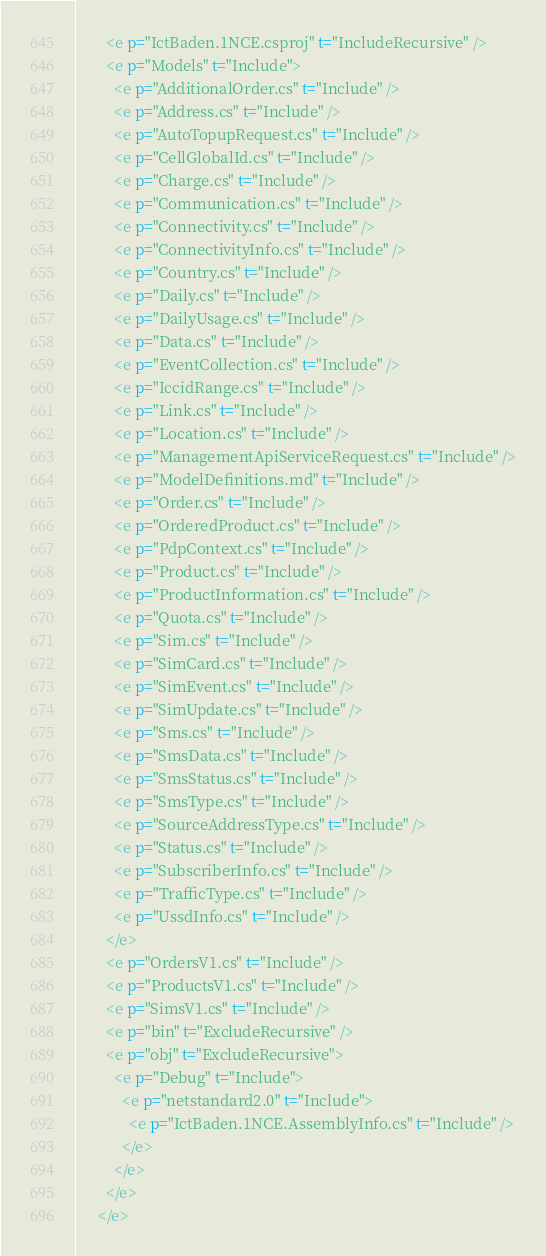<code> <loc_0><loc_0><loc_500><loc_500><_XML_>        <e p="IctBaden.1NCE.csproj" t="IncludeRecursive" />
        <e p="Models" t="Include">
          <e p="AdditionalOrder.cs" t="Include" />
          <e p="Address.cs" t="Include" />
          <e p="AutoTopupRequest.cs" t="Include" />
          <e p="CellGlobalId.cs" t="Include" />
          <e p="Charge.cs" t="Include" />
          <e p="Communication.cs" t="Include" />
          <e p="Connectivity.cs" t="Include" />
          <e p="ConnectivityInfo.cs" t="Include" />
          <e p="Country.cs" t="Include" />
          <e p="Daily.cs" t="Include" />
          <e p="DailyUsage.cs" t="Include" />
          <e p="Data.cs" t="Include" />
          <e p="EventCollection.cs" t="Include" />
          <e p="IccidRange.cs" t="Include" />
          <e p="Link.cs" t="Include" />
          <e p="Location.cs" t="Include" />
          <e p="ManagementApiServiceRequest.cs" t="Include" />
          <e p="ModelDefinitions.md" t="Include" />
          <e p="Order.cs" t="Include" />
          <e p="OrderedProduct.cs" t="Include" />
          <e p="PdpContext.cs" t="Include" />
          <e p="Product.cs" t="Include" />
          <e p="ProductInformation.cs" t="Include" />
          <e p="Quota.cs" t="Include" />
          <e p="Sim.cs" t="Include" />
          <e p="SimCard.cs" t="Include" />
          <e p="SimEvent.cs" t="Include" />
          <e p="SimUpdate.cs" t="Include" />
          <e p="Sms.cs" t="Include" />
          <e p="SmsData.cs" t="Include" />
          <e p="SmsStatus.cs" t="Include" />
          <e p="SmsType.cs" t="Include" />
          <e p="SourceAddressType.cs" t="Include" />
          <e p="Status.cs" t="Include" />
          <e p="SubscriberInfo.cs" t="Include" />
          <e p="TrafficType.cs" t="Include" />
          <e p="UssdInfo.cs" t="Include" />
        </e>
        <e p="OrdersV1.cs" t="Include" />
        <e p="ProductsV1.cs" t="Include" />
        <e p="SimsV1.cs" t="Include" />
        <e p="bin" t="ExcludeRecursive" />
        <e p="obj" t="ExcludeRecursive">
          <e p="Debug" t="Include">
            <e p="netstandard2.0" t="Include">
              <e p="IctBaden.1NCE.AssemblyInfo.cs" t="Include" />
            </e>
          </e>
        </e>
      </e></code> 